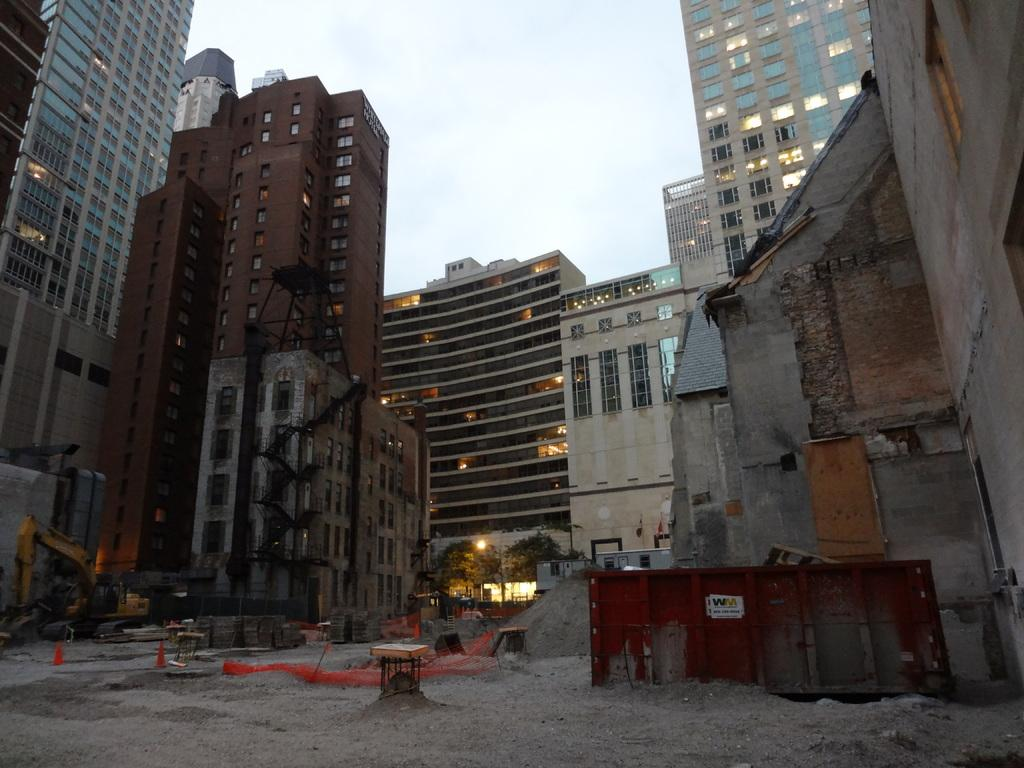What type of structures can be seen in the image? There are buildings in the image. What else can be seen in the image besides buildings? There are trees, lights, construction equipment, and traffic cones in the image. What is the surface visible at the bottom of the image? There is ground visible at the bottom of the image. Can you see the mom folding clothes in the image? There is no mom or any clothes-folding activity present in the image. 